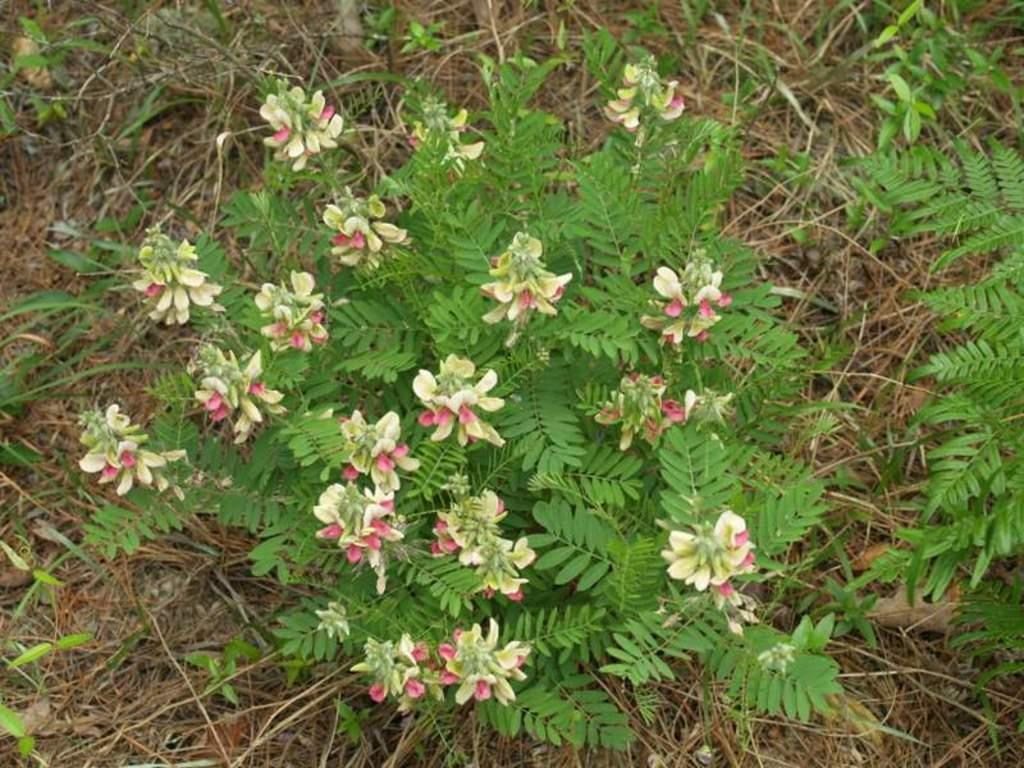What type of plant is visible in the image? There is a plant with flowers in the image. Are there any other plants in the image? Yes, there are other plants in the image. What is on the ground in the image? There is dried grass on the ground in the image. What type of cracker is being used to create the trail in the image? There is no cracker or trail present in the image; it features plants and dried grass. 